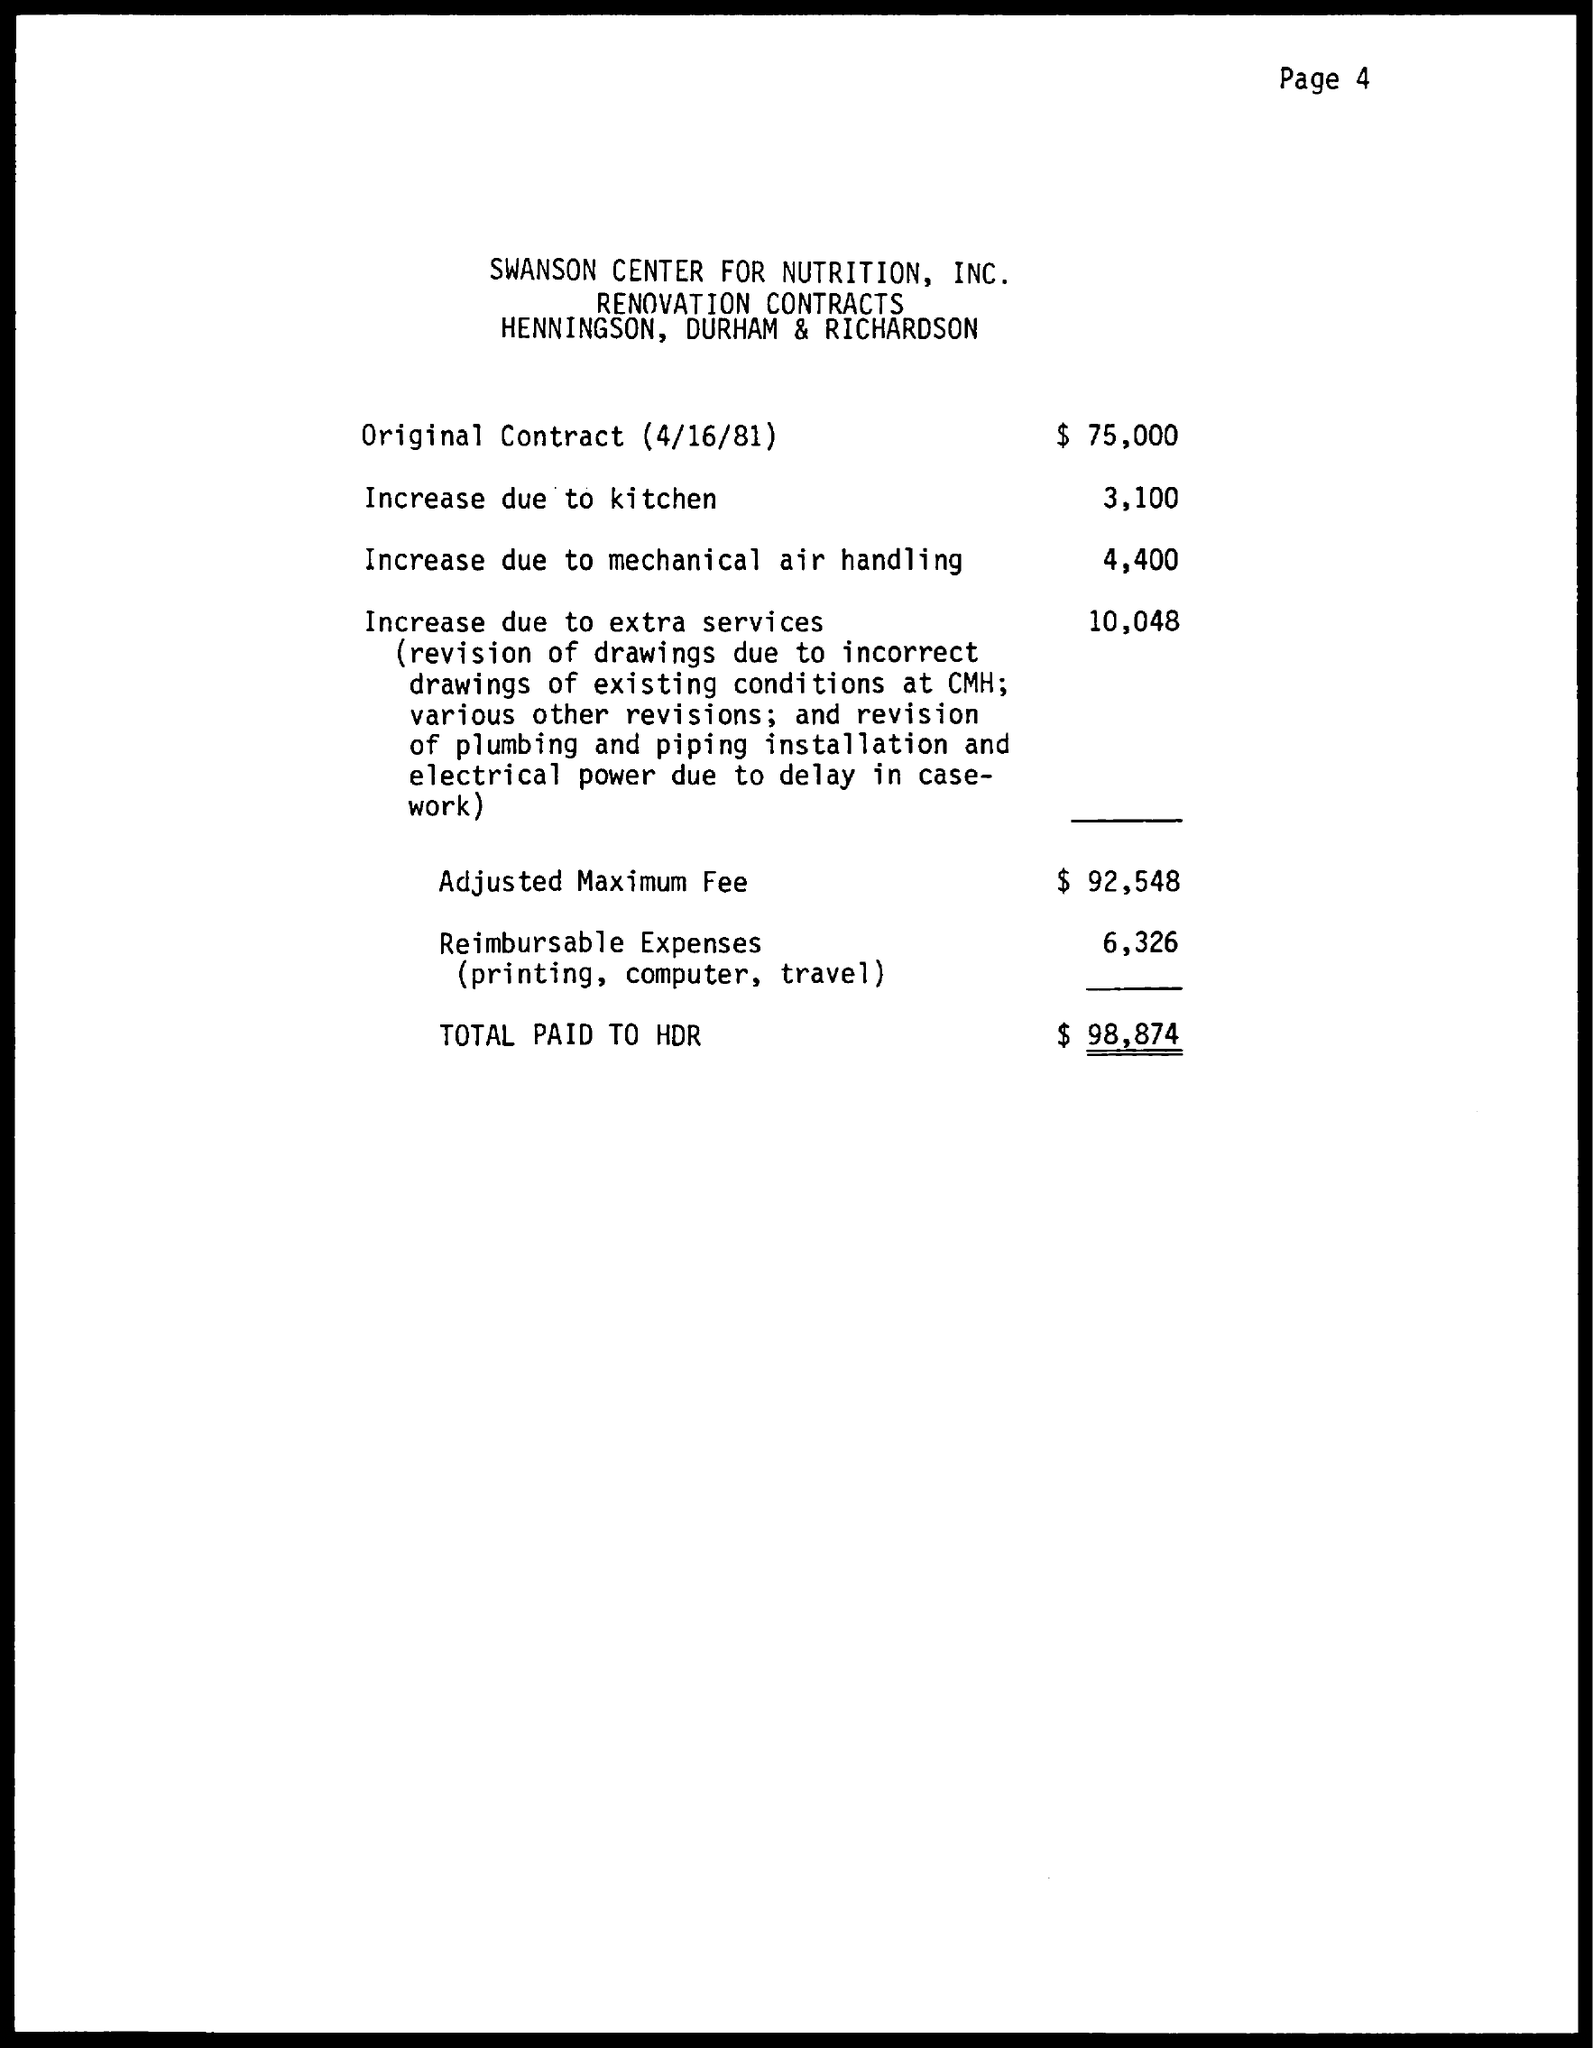What is the Total?
Offer a very short reply. $ 98,874. What is the date mentioned in the document?
Your answer should be compact. 4/16/81. What is the first title in the document?
Offer a very short reply. Swanson Center for Nutrition, Inc. 